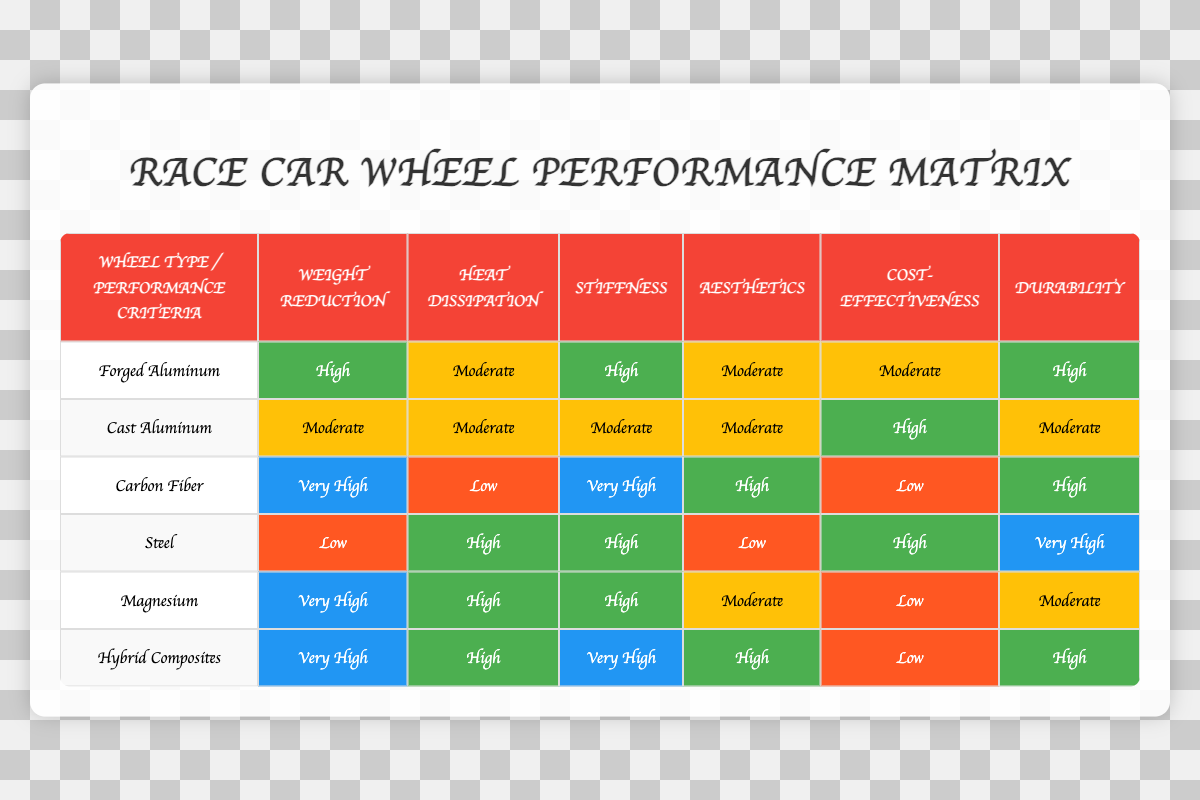What is the performance improvement rating of Cast Aluminum? According to the table, Cast Aluminum has a performance improvement rating of "Moderate."
Answer: Moderate Which wheel type has the highest performance in terms of stiffness? The table indicates that both Carbon Fiber and Hybrid Composites have a performance improvement rating of "Very High" for stiffness, making them the top-performing wheel types in that category.
Answer: Carbon Fiber and Hybrid Composites Is the performance effect for Heat Dissipation the same for Forged Aluminum and Steel? The table shows that Forged Aluminum has a performance effect rating of "Moderate" for Heat Dissipation, while Steel has a rating of "High." Thus, they do not have the same performance effect.
Answer: No What is the average performance improvement for wheel types with a "High" rating? From the table, the wheel types with a "High" performance improvement are Forged Aluminum, Magnesium, and Hybrid Composites. The total number of high ratings is 3. The average, considering that "High" is one level (compared to other ratings), is also "High."
Answer: High Which wheel type has the best performance in Weight Reduction? The table reveals that Carbon Fiber has the highest rating of "Very High" for Weight Reduction. Therefore, it outperforms all other wheel types in this category.
Answer: Carbon Fiber Are there any wheel types that have both "Very High" performance in Stiffness and High performance in Weight Reduction? Examining the table, Hybrid Composites have a "Very High" rating for Stiffness and a "Very High" rating for Weight Reduction, which qualifies them as the only wheel type meeting both criteria.
Answer: Yes How many wheel types have a "Low" rating in Cost-effectiveness? Checking the Cost-effectiveness column, the wheel types identified as having a "Low" rating are Carbon Fiber and Magnesium, totaling two types.
Answer: 2 What is the difference in performance ratings for Durability between Steel and Carbon Fiber? Observing the table shows Steel has a "Very High" rating for Durability, whereas Carbon Fiber has a "High" rating. Therefore, the difference in their performance ratings is one level, with Steel performing better.
Answer: 1 level Is there a wheel type that performs moderately across multiple criteria? Upon reviewing the table, Cast Aluminum shows "Moderate" ratings for Heat Dissipation, Stiffness, Aesthetics, and Cost-effectiveness, indicating it performs moderately across these categories.
Answer: Yes 